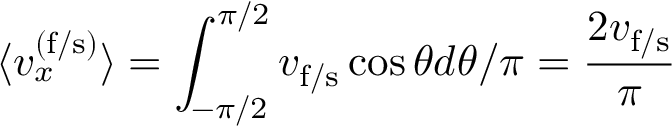<formula> <loc_0><loc_0><loc_500><loc_500>\langle v _ { x } ^ { ( f / s ) } \rangle = \int _ { - \pi / 2 } ^ { \pi / 2 } v _ { f / s } \cos \theta d \theta / \pi = \frac { 2 v _ { f / s } } { \pi }</formula> 